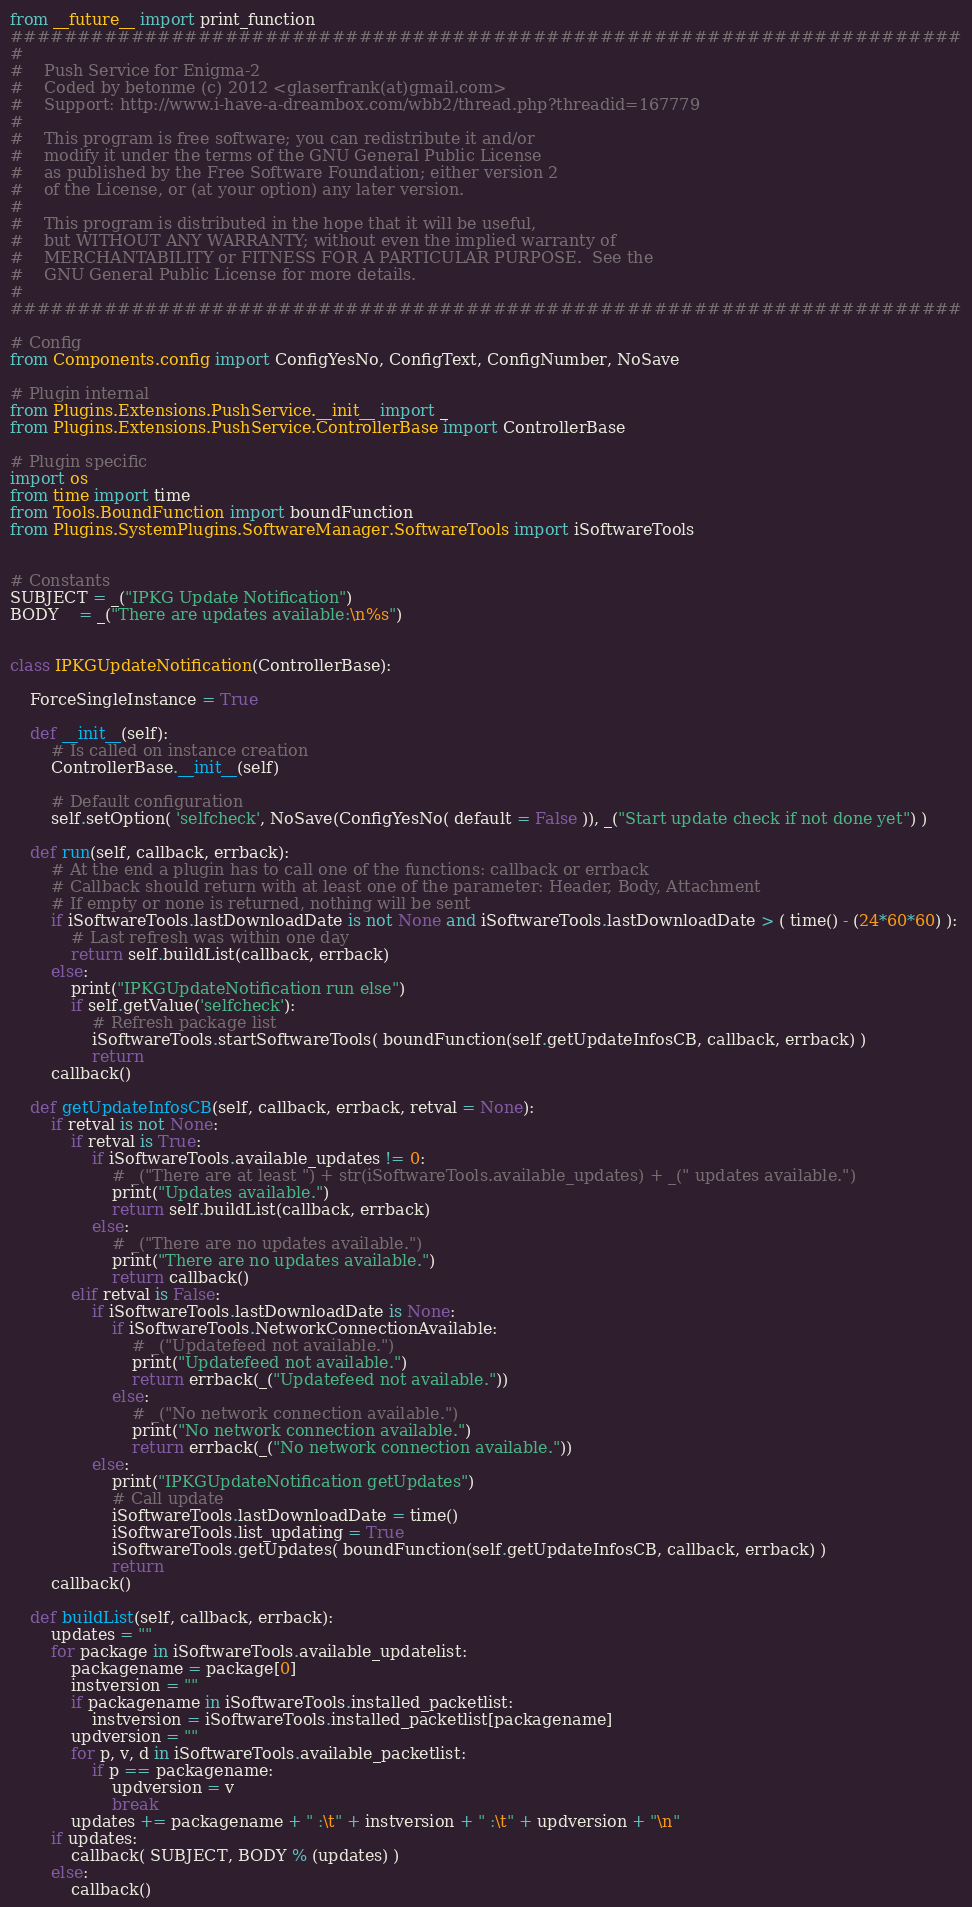<code> <loc_0><loc_0><loc_500><loc_500><_Python_>from __future__ import print_function
#######################################################################
#
#    Push Service for Enigma-2
#    Coded by betonme (c) 2012 <glaserfrank(at)gmail.com>
#    Support: http://www.i-have-a-dreambox.com/wbb2/thread.php?threadid=167779
#
#    This program is free software; you can redistribute it and/or
#    modify it under the terms of the GNU General Public License
#    as published by the Free Software Foundation; either version 2
#    of the License, or (at your option) any later version.
#
#    This program is distributed in the hope that it will be useful,
#    but WITHOUT ANY WARRANTY; without even the implied warranty of
#    MERCHANTABILITY or FITNESS FOR A PARTICULAR PURPOSE.  See the
#    GNU General Public License for more details.
#
#######################################################################

# Config
from Components.config import ConfigYesNo, ConfigText, ConfigNumber, NoSave

# Plugin internal
from Plugins.Extensions.PushService.__init__ import _
from Plugins.Extensions.PushService.ControllerBase import ControllerBase

# Plugin specific
import os
from time import time
from Tools.BoundFunction import boundFunction
from Plugins.SystemPlugins.SoftwareManager.SoftwareTools import iSoftwareTools


# Constants
SUBJECT = _("IPKG Update Notification")
BODY    = _("There are updates available:\n%s")


class IPKGUpdateNotification(ControllerBase):
	
	ForceSingleInstance = True
	
	def __init__(self):
		# Is called on instance creation
		ControllerBase.__init__(self)
		
		# Default configuration
		self.setOption( 'selfcheck', NoSave(ConfigYesNo( default = False )), _("Start update check if not done yet") )

	def run(self, callback, errback):
		# At the end a plugin has to call one of the functions: callback or errback
		# Callback should return with at least one of the parameter: Header, Body, Attachment
		# If empty or none is returned, nothing will be sent
		if iSoftwareTools.lastDownloadDate is not None and iSoftwareTools.lastDownloadDate > ( time() - (24*60*60) ):
			# Last refresh was within one day
			return self.buildList(callback, errback)
		else:
			print("IPKGUpdateNotification run else")
			if self.getValue('selfcheck'):
				# Refresh package list
				iSoftwareTools.startSoftwareTools( boundFunction(self.getUpdateInfosCB, callback, errback) )
				return
		callback()

	def getUpdateInfosCB(self, callback, errback, retval = None):
		if retval is not None:
			if retval is True:
				if iSoftwareTools.available_updates != 0:
					# _("There are at least ") + str(iSoftwareTools.available_updates) + _(" updates available.")
					print("Updates available.")
					return self.buildList(callback, errback)
				else:
					# _("There are no updates available.")
					print("There are no updates available.")
					return callback()
			elif retval is False:
				if iSoftwareTools.lastDownloadDate is None:
					if iSoftwareTools.NetworkConnectionAvailable:
						# _("Updatefeed not available.")
						print("Updatefeed not available.")
						return errback(_("Updatefeed not available."))
					else:
						# _("No network connection available.")
						print("No network connection available.")
						return errback(_("No network connection available."))
				else:
					print("IPKGUpdateNotification getUpdates")
					# Call update
					iSoftwareTools.lastDownloadDate = time()
					iSoftwareTools.list_updating = True
					iSoftwareTools.getUpdates( boundFunction(self.getUpdateInfosCB, callback, errback) )
					return
		callback()

	def buildList(self, callback, errback):
		updates = ""
		for package in iSoftwareTools.available_updatelist:
			packagename = package[0]
			instversion = ""
			if packagename in iSoftwareTools.installed_packetlist:
				instversion = iSoftwareTools.installed_packetlist[packagename]
			updversion = ""
			for p, v, d in iSoftwareTools.available_packetlist:
				if p == packagename:
					updversion = v
					break
			updates += packagename + " :\t" + instversion + " :\t" + updversion + "\n"
		if updates:
			callback( SUBJECT, BODY % (updates) )
		else:
			callback()

</code> 